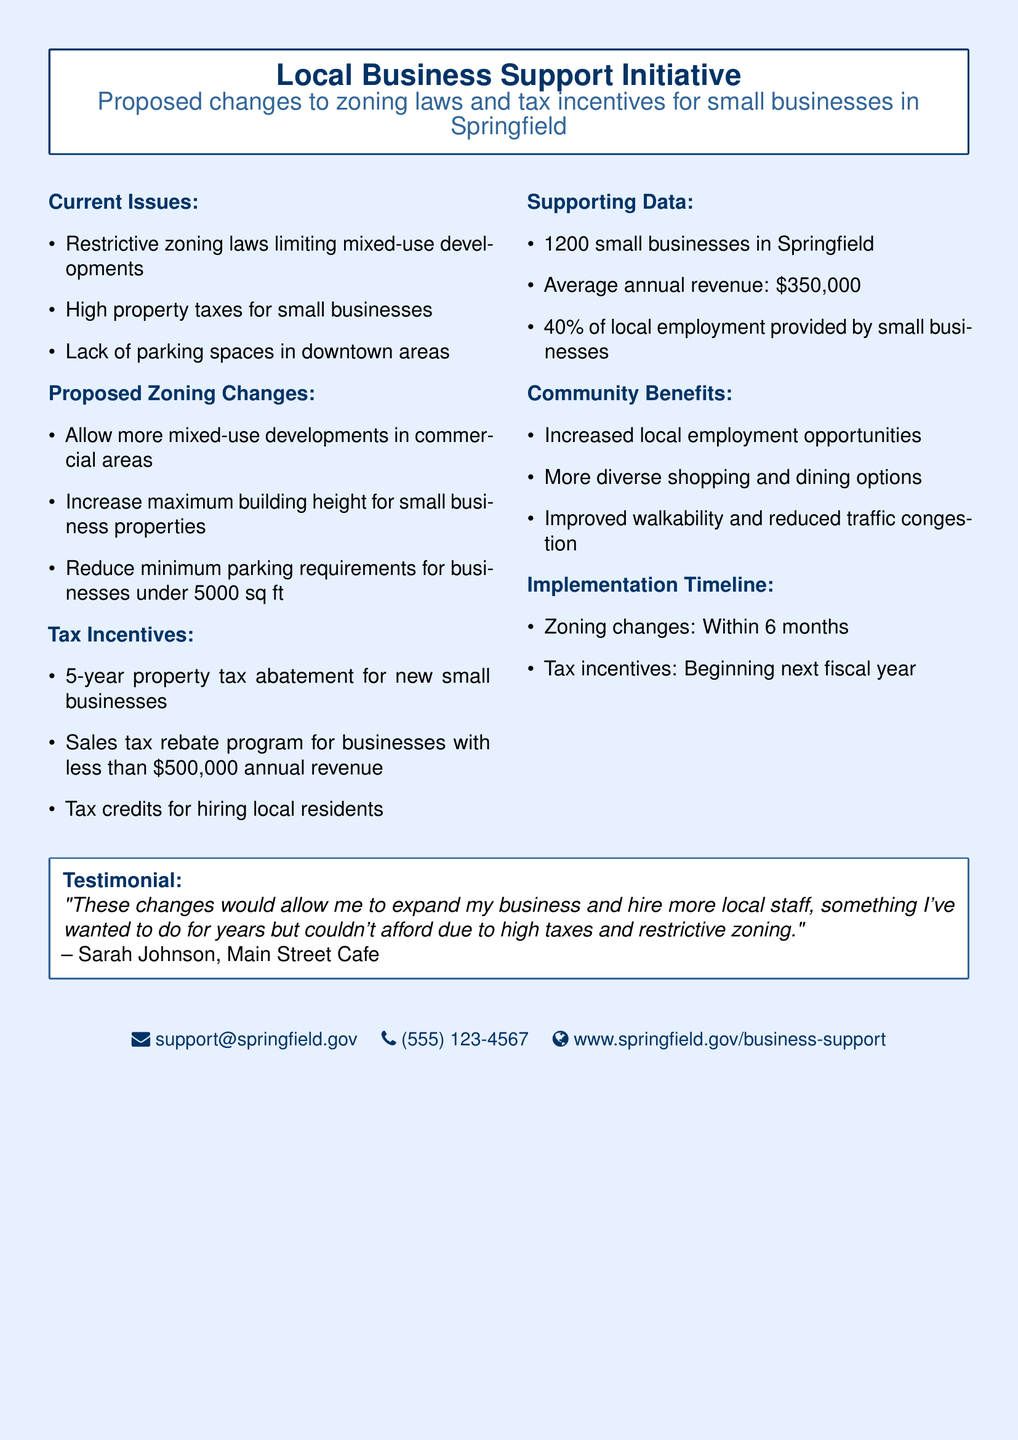What are the current issues facing small businesses? The current issues include restrictive zoning laws, high property taxes, and lack of parking spaces.
Answer: Restrictive zoning laws, high property taxes, lack of parking spaces What is the proposed maximum building height increase? The document states there is an increase in maximum building height for small business properties but does not specify the exact number.
Answer: Not specified What is the duration of the property tax abatement for new small businesses? The property tax abatement for new small businesses lasts for a specified period in the document.
Answer: 5 years What percentage of local employment is provided by small businesses? According to the document, small businesses provide a significant portion of local employment.
Answer: 40% When will the zoning changes be implemented? The implementation timeline for zoning changes is clearly stated in the document.
Answer: Within 6 months Who provided a testimonial regarding the proposed changes? The document includes a testimonial, giving credit to a local business owner expressing support for the changes.
Answer: Sarah Johnson, Main Street Cafe What is the estimated average revenue for small businesses in Springfield? The estimated average revenue provides insight into the financial status of small businesses mentioned in the document.
Answer: $350,000 What community benefit involves reducing traffic congestion? The community benefits section outlines improved walkability, which relates to reducing traffic congestion.
Answer: Improved walkability and reduced traffic congestion What is the sales tax rebate program threshold for businesses? The document mentions a sales tax rebate program focusing on revenue thresholds for qualifying businesses.
Answer: Less than $500,000 annual revenue 